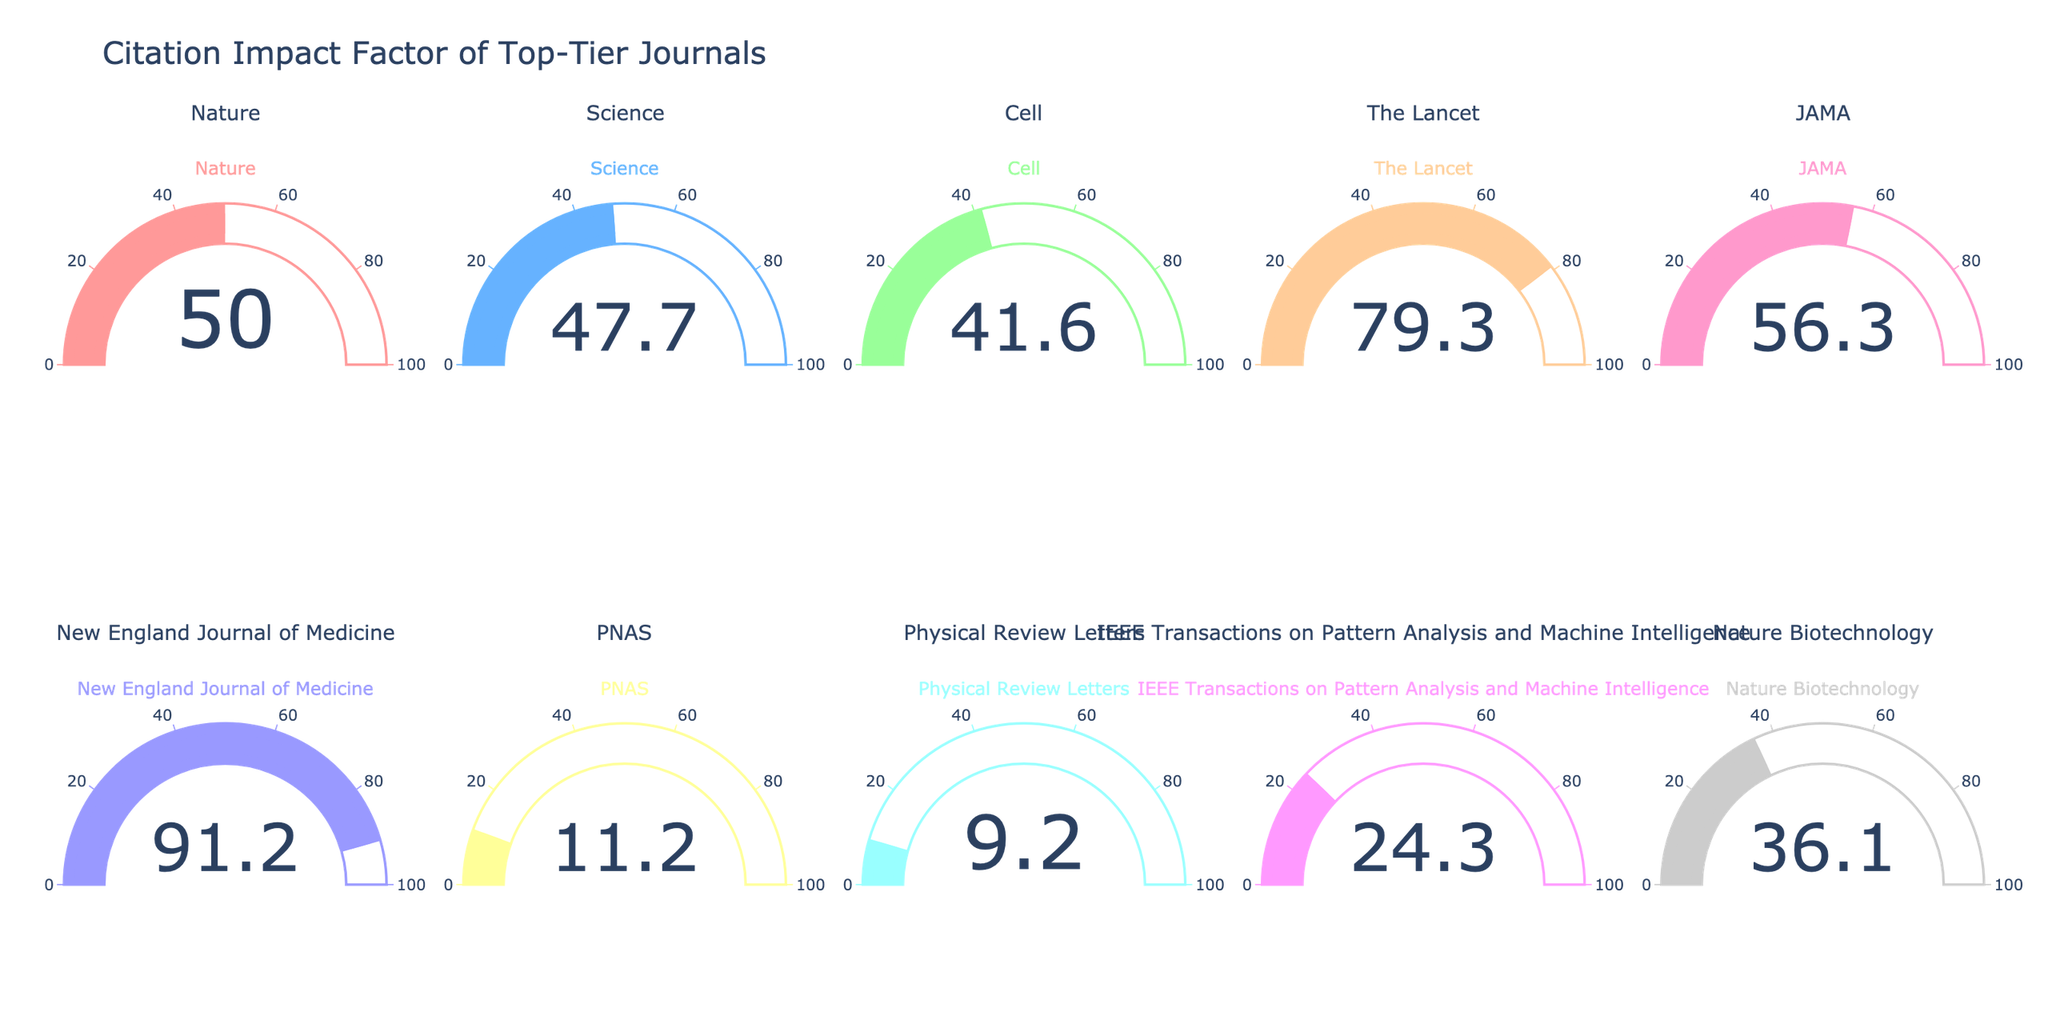what is the title of the figure? The title of the figure is displayed at the top. It indicates the overall theme of the chart, which in this case is about citation impact factors of top-tier journals.
Answer: Citation Impact Factor of Top-Tier Journals How many journals are displayed in the gauge chart? There are two rows, each containing five gauge charts, for a total of ten charts.
Answer: 10 Which journal has the highest impact factor? Look for the gauge chart with the highest number. The journal title for this gauge will be the one with the highest impact factor.
Answer: New England Journal of Medicine What is the impact factor of 'Nature'? Locate the gauge chart titled 'Nature' and read the associated number.
Answer: 49.96 What is the difference in Impact Factor between JAMA and The Lancet? Identify the impact factors of JAMA and The Lancet from their respective gauge charts and calculate the difference: 56.27 - 79.32 = -23.05.
Answer: -23.05 Which journals have an impact factor greater than 50? Look for any gauge charts with a number above 50. The journals with such values are New England Journal of Medicine, The Lancet, and JAMA.
Answer: New England Journal of Medicine, The Lancet, JAMA What is the average impact factor of all journals displayed? Sum all the impact factors and divide by the number of journals: (49.96 + 47.73 + 41.58 + 79.32 + 56.27 + 91.24 + 11.21 + 9.16 + 24.31 + 36.13) / 10 = 44.591.
Answer: 44.591 What is the median impact factor of the journals? Arrange the impact factors in numerical order and find the middle value. If there is an even number of data points, average the two middle values: (9.16, 11.21, 24.31, 36.13, 41.58, 47.73, 49.96, 56.27, 79.32, 91.24). The median of these values is (41.58 + 47.73) / 2 = 44.655.
Answer: 44.655 Which journal's gauge is represented with a purple color? Locate the journal with the gauge bar colored purple. This is unique for Physical Review Letters ("#9999FF").
Answer: Physical Review Letters Which journal shows a gauge reading of exactly 36.13? Find the gauge chart where the number displayed inside the gauge is 36.13 and identify the journal name associated with it.
Answer: Nature Biotechnology 